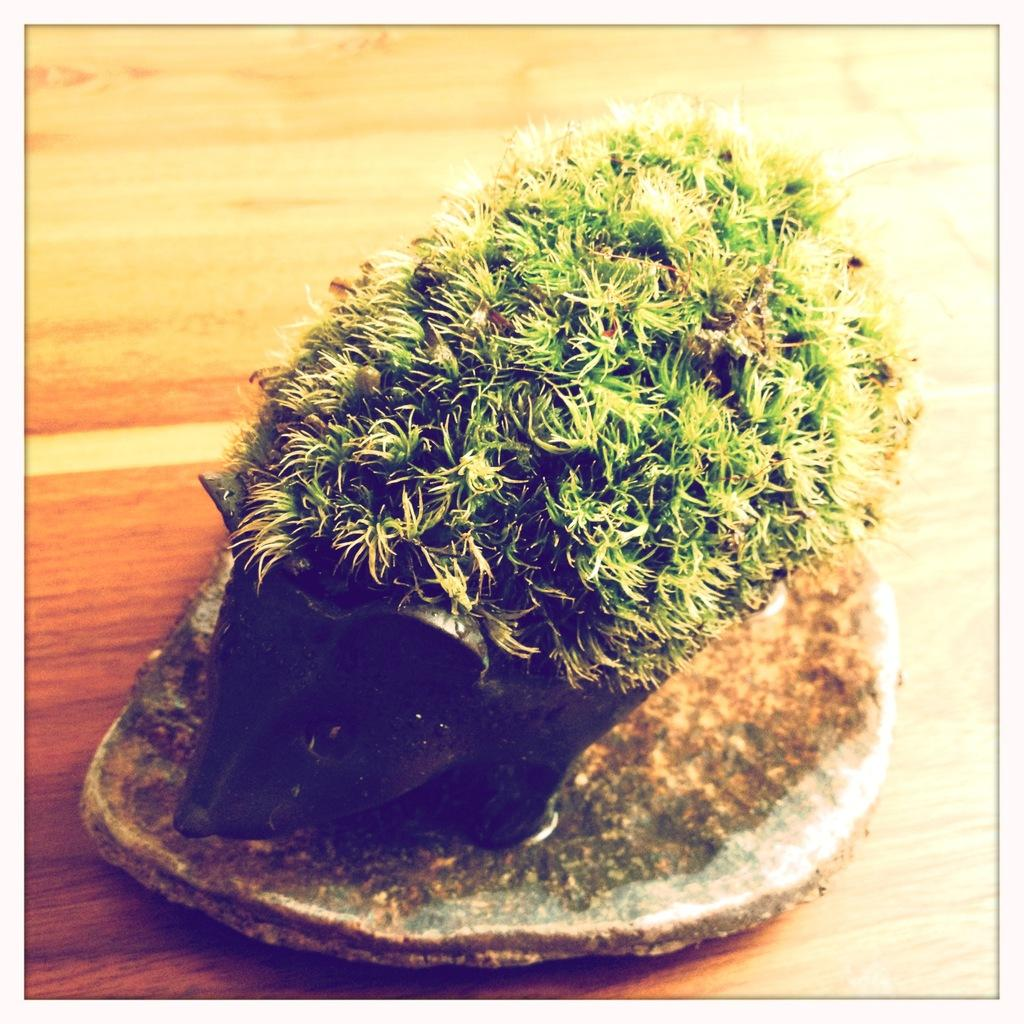What type of living organism can be seen in the image? There is a plant in the image. What color is the pot that the plant is in? The pot is black-colored. What is the color of the surface under the pot? The surface under the pot is brown-colored. What type of instrument is being played by the plant in the image? There is no instrument being played by the plant in the image, as plants do not have the ability to play instruments. 